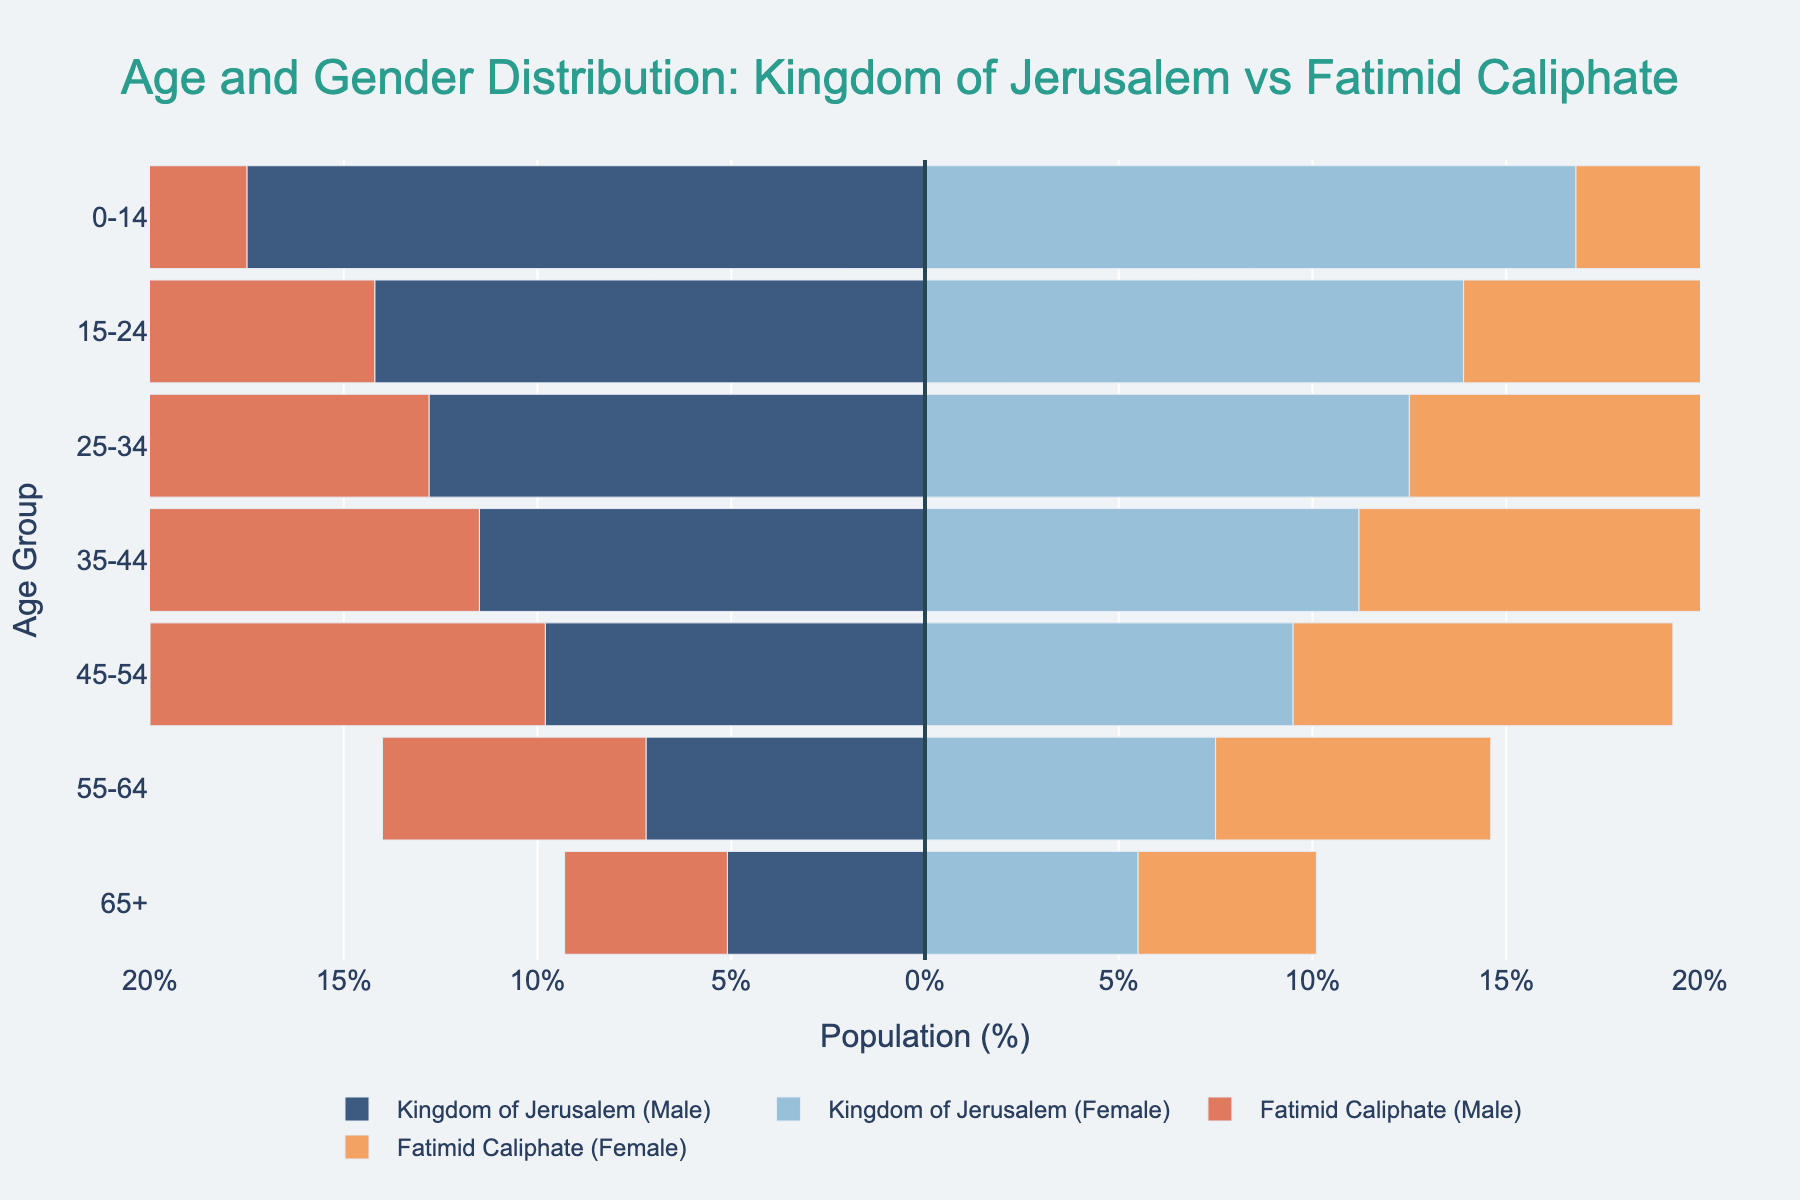What age group has the highest percentage of males in the Kingdom of Jerusalem? The tallest bar on the left side for the Kingdom of Jerusalem (Male) is in the 0-14 age group with a value of 17.5%.
Answer: 0-14 Which age group has the smallest percentage of females in the Fatimid Caliphate? The shortest bar on the right side for the Fatimid Caliphate (Female) is in the 65+ age group with a value of 4.6%.
Answer: 65+ What is the combined percentage of males and females aged 25-34 in the Kingdom of Jerusalem? Adding the two values from the 25-34 age group for the Kingdom of Jerusalem: 12.8% (Male) + 12.5% (Female) = 25.3%.
Answer: 25.3% How does the percentage of the 55-64 age group compare between males in the Kingdom of Jerusalem and males in the Fatimid Caliphate? The 55-64 age group has 7.2% males in the Kingdom of Jerusalem and 6.8% males in the Fatimid Caliphate. Comparing these values, 7.2% > 6.8%.
Answer: Kingdom of Jerusalem males have higher Which gender has a more balanced distribution between the Kingdom of Jerusalem and the Fatimid Caliphate across all age groups? To determine which has a more balanced distribution, check the side-by-side heights of the corresponding gender bars across age groups. Both male and female distributions have some variation, but female distributions appear slightly more balanced.
Answer: Females In the 45-54 age group, what is the difference in percentage between females in the Kingdom of Jerusalem and females in the Fatimid Caliphate? Subtract the percentage of the Fatimid Caliphate females (9.8%) from the Kingdom of Jerusalem females (9.5%) in the 45-54 age group: 9.8% - 9.5% = 0.3%.
Answer: 0.3% What age group has the closest percentage of males and females in the Fatimid Caliphate? Comparing the percentages for each age group within the Fatimid Caliphate, the 65+ age group has the closest percentages: males (4.2%) and females (4.6%).
Answer: 65+ Which kingdom shows a higher percentage of young population (0-14 years) for both males and females combined? Sum the 0-14 age group percentages for each kingdom: 
- Kingdom of Jerusalem: 17.5% (Male) + 16.8% (Female) = 34.3%
- Fatimid Caliphate: 19.2% (Male) + 18.5% (Female) = 37.7%
The Fatimid Caliphate has a higher combined percentage.
Answer: Fatimid Caliphate 